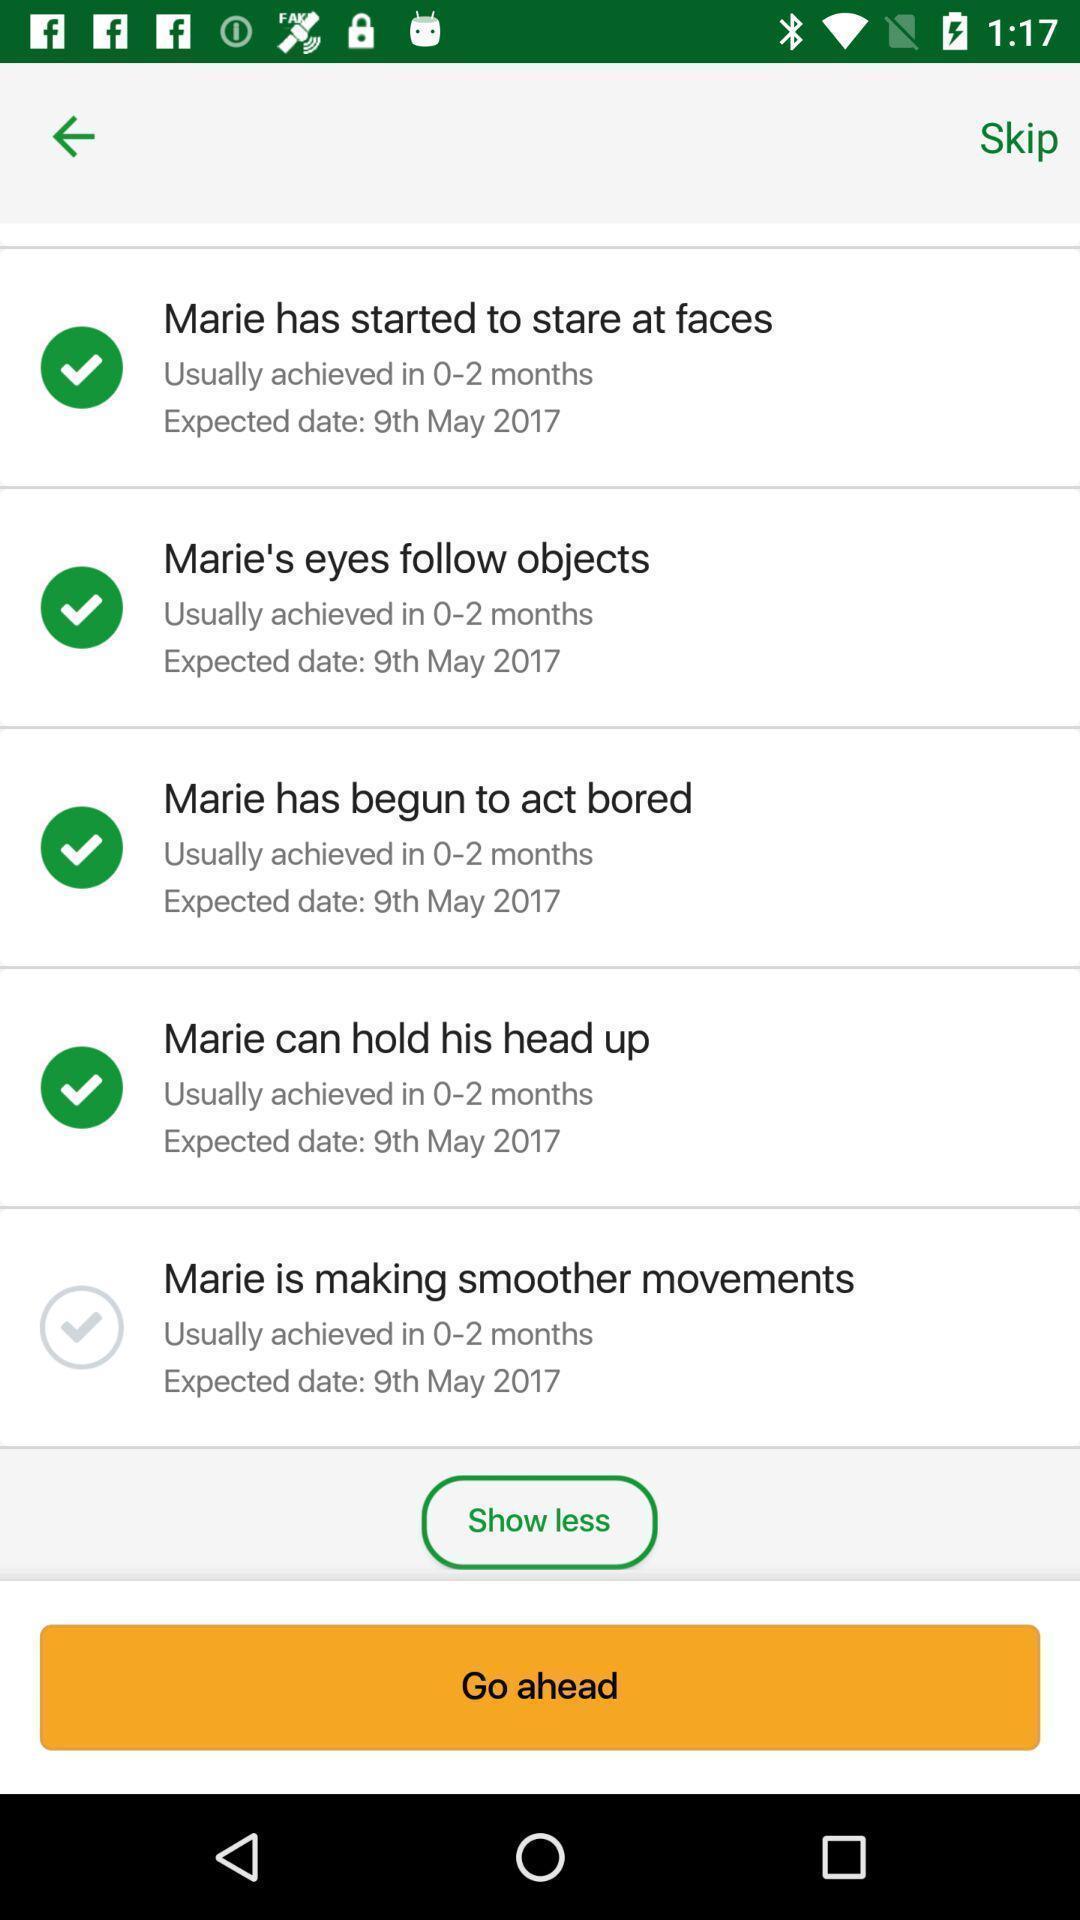Provide a textual representation of this image. Screen shows list of options in a health app. 